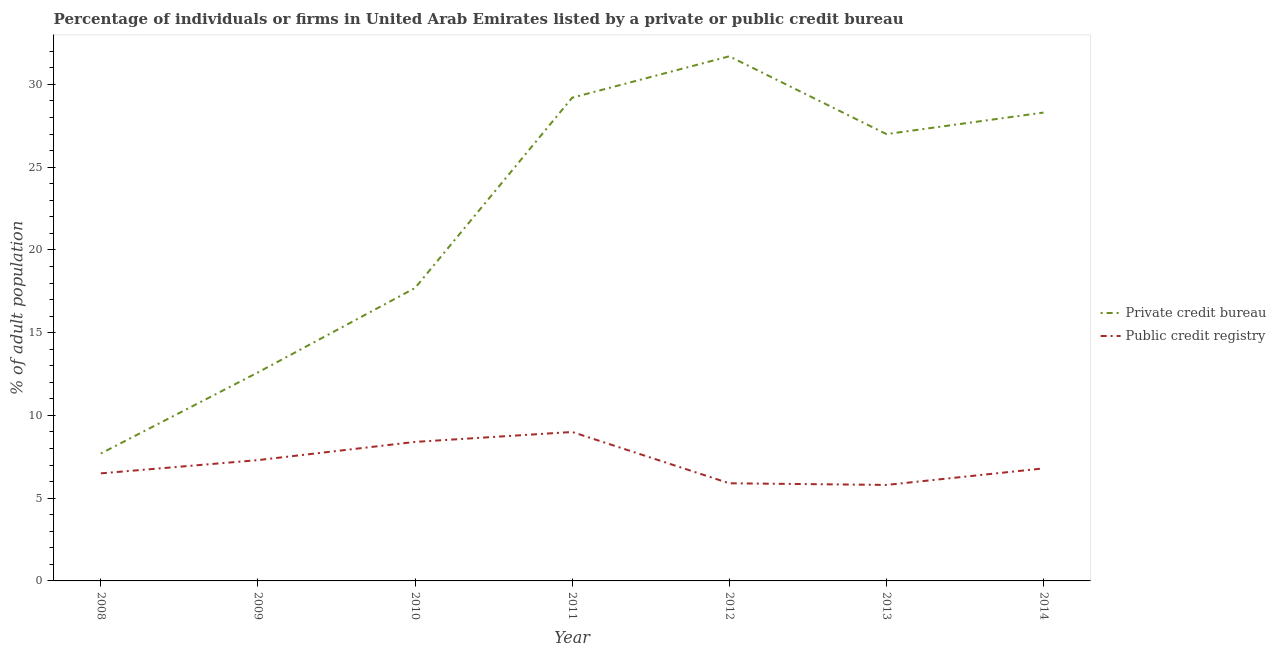What is the percentage of firms listed by public credit bureau in 2014?
Ensure brevity in your answer.  6.8. Across all years, what is the maximum percentage of firms listed by private credit bureau?
Offer a terse response. 31.7. In which year was the percentage of firms listed by public credit bureau maximum?
Ensure brevity in your answer.  2011. What is the total percentage of firms listed by private credit bureau in the graph?
Your response must be concise. 154.2. What is the difference between the percentage of firms listed by private credit bureau in 2009 and that in 2011?
Provide a short and direct response. -16.6. What is the difference between the percentage of firms listed by public credit bureau in 2012 and the percentage of firms listed by private credit bureau in 2014?
Provide a short and direct response. -22.4. In the year 2011, what is the difference between the percentage of firms listed by public credit bureau and percentage of firms listed by private credit bureau?
Your answer should be compact. -20.2. In how many years, is the percentage of firms listed by public credit bureau greater than 11 %?
Offer a terse response. 0. What is the ratio of the percentage of firms listed by public credit bureau in 2010 to that in 2011?
Your answer should be compact. 0.93. Is the percentage of firms listed by private credit bureau in 2010 less than that in 2011?
Provide a succinct answer. Yes. Is the difference between the percentage of firms listed by private credit bureau in 2009 and 2012 greater than the difference between the percentage of firms listed by public credit bureau in 2009 and 2012?
Ensure brevity in your answer.  No. What is the difference between the highest and the lowest percentage of firms listed by private credit bureau?
Give a very brief answer. 24. Is the sum of the percentage of firms listed by public credit bureau in 2008 and 2011 greater than the maximum percentage of firms listed by private credit bureau across all years?
Keep it short and to the point. No. Is the percentage of firms listed by public credit bureau strictly greater than the percentage of firms listed by private credit bureau over the years?
Keep it short and to the point. No. Is the percentage of firms listed by public credit bureau strictly less than the percentage of firms listed by private credit bureau over the years?
Your response must be concise. Yes. What is the difference between two consecutive major ticks on the Y-axis?
Provide a succinct answer. 5. Are the values on the major ticks of Y-axis written in scientific E-notation?
Make the answer very short. No. Does the graph contain any zero values?
Offer a very short reply. No. How are the legend labels stacked?
Keep it short and to the point. Vertical. What is the title of the graph?
Offer a terse response. Percentage of individuals or firms in United Arab Emirates listed by a private or public credit bureau. What is the label or title of the Y-axis?
Keep it short and to the point. % of adult population. What is the % of adult population in Private credit bureau in 2008?
Keep it short and to the point. 7.7. What is the % of adult population of Private credit bureau in 2010?
Your answer should be compact. 17.7. What is the % of adult population of Public credit registry in 2010?
Your answer should be compact. 8.4. What is the % of adult population of Private credit bureau in 2011?
Make the answer very short. 29.2. What is the % of adult population in Private credit bureau in 2012?
Provide a short and direct response. 31.7. What is the % of adult population of Public credit registry in 2013?
Give a very brief answer. 5.8. What is the % of adult population in Private credit bureau in 2014?
Give a very brief answer. 28.3. What is the % of adult population in Public credit registry in 2014?
Offer a very short reply. 6.8. Across all years, what is the maximum % of adult population in Private credit bureau?
Ensure brevity in your answer.  31.7. Across all years, what is the maximum % of adult population of Public credit registry?
Provide a succinct answer. 9. Across all years, what is the minimum % of adult population in Public credit registry?
Provide a succinct answer. 5.8. What is the total % of adult population of Private credit bureau in the graph?
Provide a short and direct response. 154.2. What is the total % of adult population in Public credit registry in the graph?
Offer a very short reply. 49.7. What is the difference between the % of adult population of Private credit bureau in 2008 and that in 2009?
Your response must be concise. -4.9. What is the difference between the % of adult population of Private credit bureau in 2008 and that in 2010?
Offer a very short reply. -10. What is the difference between the % of adult population of Public credit registry in 2008 and that in 2010?
Make the answer very short. -1.9. What is the difference between the % of adult population in Private credit bureau in 2008 and that in 2011?
Make the answer very short. -21.5. What is the difference between the % of adult population in Public credit registry in 2008 and that in 2011?
Offer a terse response. -2.5. What is the difference between the % of adult population of Private credit bureau in 2008 and that in 2013?
Ensure brevity in your answer.  -19.3. What is the difference between the % of adult population of Public credit registry in 2008 and that in 2013?
Provide a succinct answer. 0.7. What is the difference between the % of adult population in Private credit bureau in 2008 and that in 2014?
Give a very brief answer. -20.6. What is the difference between the % of adult population in Public credit registry in 2008 and that in 2014?
Provide a short and direct response. -0.3. What is the difference between the % of adult population of Private credit bureau in 2009 and that in 2011?
Your answer should be compact. -16.6. What is the difference between the % of adult population in Private credit bureau in 2009 and that in 2012?
Your answer should be very brief. -19.1. What is the difference between the % of adult population of Private credit bureau in 2009 and that in 2013?
Keep it short and to the point. -14.4. What is the difference between the % of adult population in Public credit registry in 2009 and that in 2013?
Give a very brief answer. 1.5. What is the difference between the % of adult population in Private credit bureau in 2009 and that in 2014?
Give a very brief answer. -15.7. What is the difference between the % of adult population of Private credit bureau in 2010 and that in 2011?
Your answer should be very brief. -11.5. What is the difference between the % of adult population in Public credit registry in 2010 and that in 2011?
Make the answer very short. -0.6. What is the difference between the % of adult population of Private credit bureau in 2010 and that in 2012?
Provide a short and direct response. -14. What is the difference between the % of adult population of Public credit registry in 2010 and that in 2012?
Your answer should be very brief. 2.5. What is the difference between the % of adult population in Public credit registry in 2010 and that in 2013?
Keep it short and to the point. 2.6. What is the difference between the % of adult population in Private credit bureau in 2010 and that in 2014?
Provide a succinct answer. -10.6. What is the difference between the % of adult population in Private credit bureau in 2011 and that in 2012?
Provide a succinct answer. -2.5. What is the difference between the % of adult population in Public credit registry in 2011 and that in 2012?
Provide a short and direct response. 3.1. What is the difference between the % of adult population of Private credit bureau in 2011 and that in 2013?
Provide a succinct answer. 2.2. What is the difference between the % of adult population in Public credit registry in 2011 and that in 2014?
Ensure brevity in your answer.  2.2. What is the difference between the % of adult population of Private credit bureau in 2012 and that in 2013?
Provide a short and direct response. 4.7. What is the difference between the % of adult population of Public credit registry in 2012 and that in 2013?
Your answer should be very brief. 0.1. What is the difference between the % of adult population of Private credit bureau in 2012 and that in 2014?
Provide a short and direct response. 3.4. What is the difference between the % of adult population in Private credit bureau in 2013 and that in 2014?
Make the answer very short. -1.3. What is the difference between the % of adult population of Private credit bureau in 2008 and the % of adult population of Public credit registry in 2009?
Your answer should be compact. 0.4. What is the difference between the % of adult population of Private credit bureau in 2008 and the % of adult population of Public credit registry in 2012?
Your answer should be compact. 1.8. What is the difference between the % of adult population in Private credit bureau in 2008 and the % of adult population in Public credit registry in 2014?
Make the answer very short. 0.9. What is the difference between the % of adult population in Private credit bureau in 2009 and the % of adult population in Public credit registry in 2012?
Make the answer very short. 6.7. What is the difference between the % of adult population in Private credit bureau in 2009 and the % of adult population in Public credit registry in 2013?
Make the answer very short. 6.8. What is the difference between the % of adult population in Private credit bureau in 2010 and the % of adult population in Public credit registry in 2011?
Make the answer very short. 8.7. What is the difference between the % of adult population in Private credit bureau in 2011 and the % of adult population in Public credit registry in 2012?
Offer a very short reply. 23.3. What is the difference between the % of adult population of Private credit bureau in 2011 and the % of adult population of Public credit registry in 2013?
Provide a short and direct response. 23.4. What is the difference between the % of adult population in Private credit bureau in 2011 and the % of adult population in Public credit registry in 2014?
Ensure brevity in your answer.  22.4. What is the difference between the % of adult population of Private credit bureau in 2012 and the % of adult population of Public credit registry in 2013?
Make the answer very short. 25.9. What is the difference between the % of adult population in Private credit bureau in 2012 and the % of adult population in Public credit registry in 2014?
Give a very brief answer. 24.9. What is the difference between the % of adult population of Private credit bureau in 2013 and the % of adult population of Public credit registry in 2014?
Ensure brevity in your answer.  20.2. What is the average % of adult population of Private credit bureau per year?
Make the answer very short. 22.03. In the year 2008, what is the difference between the % of adult population of Private credit bureau and % of adult population of Public credit registry?
Give a very brief answer. 1.2. In the year 2010, what is the difference between the % of adult population in Private credit bureau and % of adult population in Public credit registry?
Your answer should be very brief. 9.3. In the year 2011, what is the difference between the % of adult population of Private credit bureau and % of adult population of Public credit registry?
Offer a very short reply. 20.2. In the year 2012, what is the difference between the % of adult population of Private credit bureau and % of adult population of Public credit registry?
Your answer should be compact. 25.8. In the year 2013, what is the difference between the % of adult population in Private credit bureau and % of adult population in Public credit registry?
Provide a succinct answer. 21.2. What is the ratio of the % of adult population in Private credit bureau in 2008 to that in 2009?
Offer a terse response. 0.61. What is the ratio of the % of adult population of Public credit registry in 2008 to that in 2009?
Keep it short and to the point. 0.89. What is the ratio of the % of adult population in Private credit bureau in 2008 to that in 2010?
Give a very brief answer. 0.43. What is the ratio of the % of adult population of Public credit registry in 2008 to that in 2010?
Ensure brevity in your answer.  0.77. What is the ratio of the % of adult population in Private credit bureau in 2008 to that in 2011?
Ensure brevity in your answer.  0.26. What is the ratio of the % of adult population of Public credit registry in 2008 to that in 2011?
Give a very brief answer. 0.72. What is the ratio of the % of adult population in Private credit bureau in 2008 to that in 2012?
Your answer should be very brief. 0.24. What is the ratio of the % of adult population in Public credit registry in 2008 to that in 2012?
Keep it short and to the point. 1.1. What is the ratio of the % of adult population in Private credit bureau in 2008 to that in 2013?
Give a very brief answer. 0.29. What is the ratio of the % of adult population in Public credit registry in 2008 to that in 2013?
Offer a very short reply. 1.12. What is the ratio of the % of adult population of Private credit bureau in 2008 to that in 2014?
Give a very brief answer. 0.27. What is the ratio of the % of adult population in Public credit registry in 2008 to that in 2014?
Provide a succinct answer. 0.96. What is the ratio of the % of adult population of Private credit bureau in 2009 to that in 2010?
Your response must be concise. 0.71. What is the ratio of the % of adult population of Public credit registry in 2009 to that in 2010?
Offer a terse response. 0.87. What is the ratio of the % of adult population of Private credit bureau in 2009 to that in 2011?
Keep it short and to the point. 0.43. What is the ratio of the % of adult population in Public credit registry in 2009 to that in 2011?
Keep it short and to the point. 0.81. What is the ratio of the % of adult population in Private credit bureau in 2009 to that in 2012?
Offer a very short reply. 0.4. What is the ratio of the % of adult population of Public credit registry in 2009 to that in 2012?
Ensure brevity in your answer.  1.24. What is the ratio of the % of adult population in Private credit bureau in 2009 to that in 2013?
Your answer should be very brief. 0.47. What is the ratio of the % of adult population in Public credit registry in 2009 to that in 2013?
Provide a succinct answer. 1.26. What is the ratio of the % of adult population of Private credit bureau in 2009 to that in 2014?
Your response must be concise. 0.45. What is the ratio of the % of adult population of Public credit registry in 2009 to that in 2014?
Give a very brief answer. 1.07. What is the ratio of the % of adult population of Private credit bureau in 2010 to that in 2011?
Keep it short and to the point. 0.61. What is the ratio of the % of adult population of Private credit bureau in 2010 to that in 2012?
Give a very brief answer. 0.56. What is the ratio of the % of adult population in Public credit registry in 2010 to that in 2012?
Provide a succinct answer. 1.42. What is the ratio of the % of adult population in Private credit bureau in 2010 to that in 2013?
Ensure brevity in your answer.  0.66. What is the ratio of the % of adult population of Public credit registry in 2010 to that in 2013?
Provide a succinct answer. 1.45. What is the ratio of the % of adult population of Private credit bureau in 2010 to that in 2014?
Provide a succinct answer. 0.63. What is the ratio of the % of adult population of Public credit registry in 2010 to that in 2014?
Offer a terse response. 1.24. What is the ratio of the % of adult population in Private credit bureau in 2011 to that in 2012?
Make the answer very short. 0.92. What is the ratio of the % of adult population in Public credit registry in 2011 to that in 2012?
Provide a short and direct response. 1.53. What is the ratio of the % of adult population of Private credit bureau in 2011 to that in 2013?
Keep it short and to the point. 1.08. What is the ratio of the % of adult population in Public credit registry in 2011 to that in 2013?
Give a very brief answer. 1.55. What is the ratio of the % of adult population in Private credit bureau in 2011 to that in 2014?
Your response must be concise. 1.03. What is the ratio of the % of adult population of Public credit registry in 2011 to that in 2014?
Make the answer very short. 1.32. What is the ratio of the % of adult population of Private credit bureau in 2012 to that in 2013?
Provide a succinct answer. 1.17. What is the ratio of the % of adult population in Public credit registry in 2012 to that in 2013?
Your response must be concise. 1.02. What is the ratio of the % of adult population of Private credit bureau in 2012 to that in 2014?
Your answer should be very brief. 1.12. What is the ratio of the % of adult population in Public credit registry in 2012 to that in 2014?
Provide a short and direct response. 0.87. What is the ratio of the % of adult population of Private credit bureau in 2013 to that in 2014?
Offer a very short reply. 0.95. What is the ratio of the % of adult population of Public credit registry in 2013 to that in 2014?
Keep it short and to the point. 0.85. What is the difference between the highest and the lowest % of adult population in Public credit registry?
Make the answer very short. 3.2. 